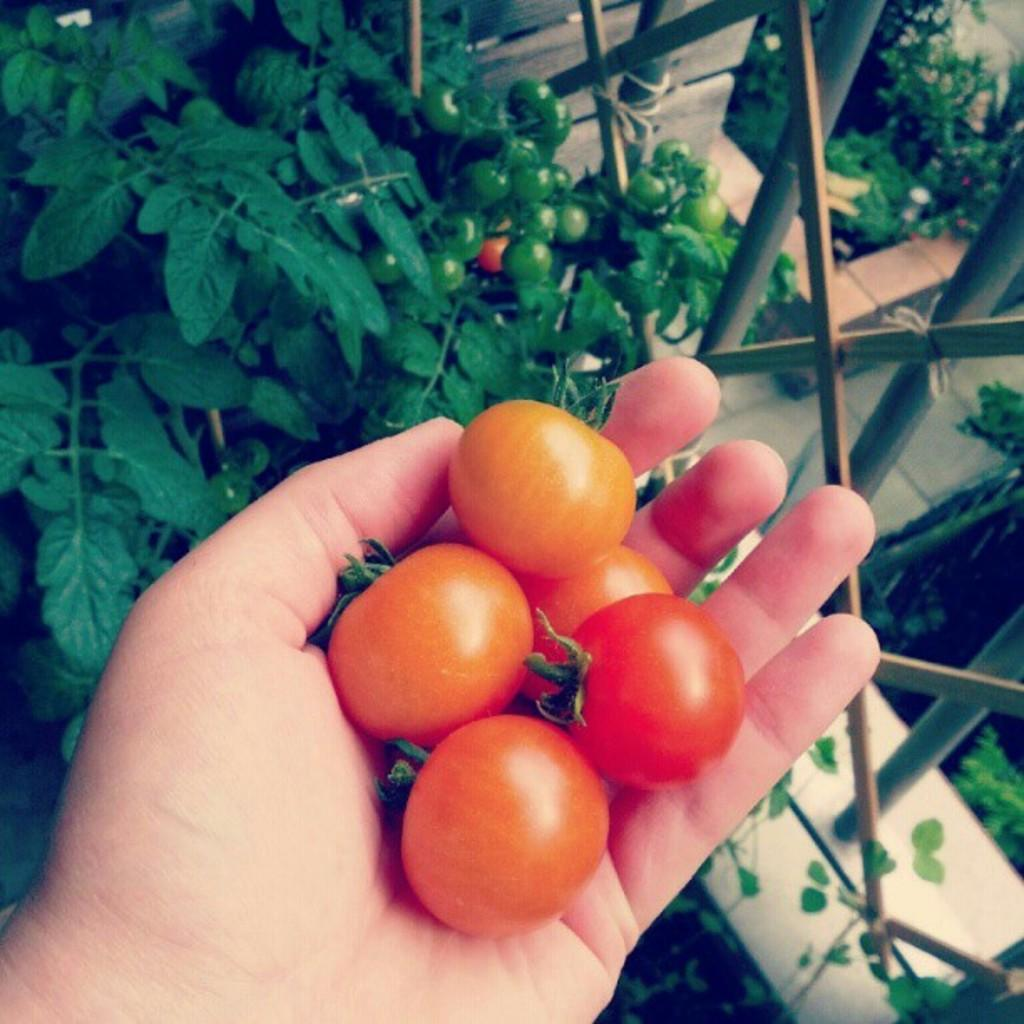What is the person holding in the image? There is a person's hand holding tomatoes in the image. What can be seen in the background of the image? There are plants in the background of the image. What type of structure is visible in the image? There is a fence visible in the image. How many rings are on the person's hand in the image? There is no mention of rings on the person's hand in the image, so we cannot determine the number of rings. What type of dogs can be seen playing with the tomatoes in the image? There are no dogs present in the image; it only features a person's hand holding tomatoes and a background with plants. 